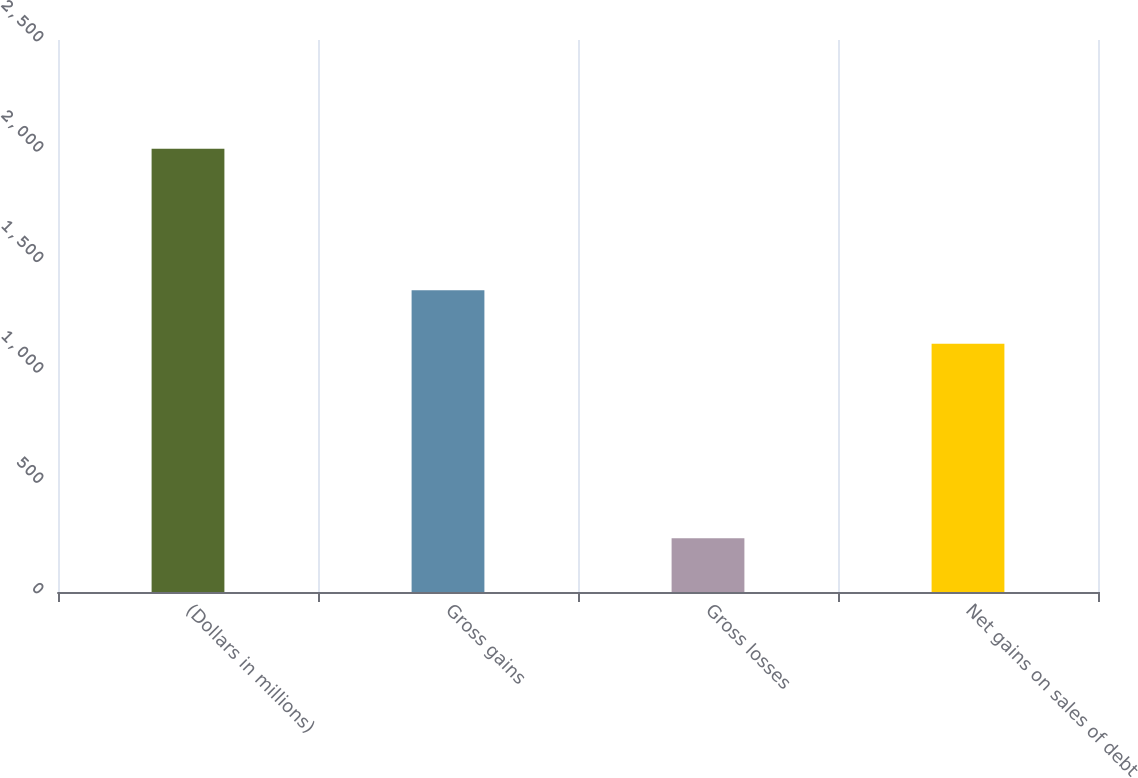Convert chart. <chart><loc_0><loc_0><loc_500><loc_500><bar_chart><fcel>(Dollars in millions)<fcel>Gross gains<fcel>Gross losses<fcel>Net gains on sales of debt<nl><fcel>2008<fcel>1367<fcel>243<fcel>1124<nl></chart> 